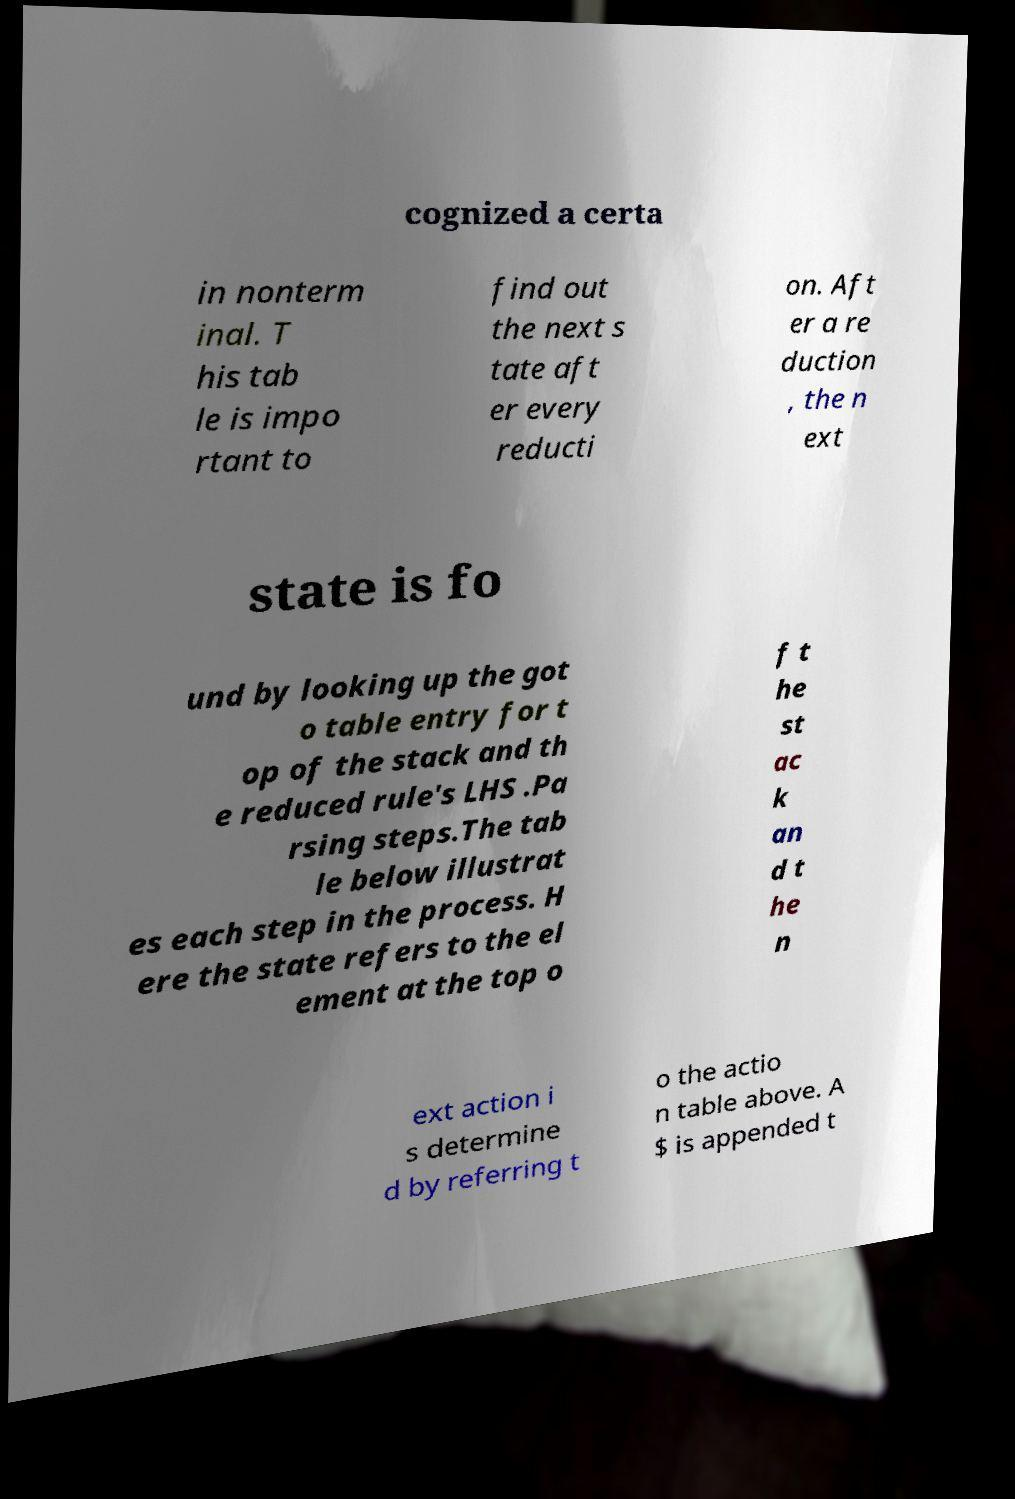I need the written content from this picture converted into text. Can you do that? cognized a certa in nonterm inal. T his tab le is impo rtant to find out the next s tate aft er every reducti on. Aft er a re duction , the n ext state is fo und by looking up the got o table entry for t op of the stack and th e reduced rule's LHS .Pa rsing steps.The tab le below illustrat es each step in the process. H ere the state refers to the el ement at the top o f t he st ac k an d t he n ext action i s determine d by referring t o the actio n table above. A $ is appended t 